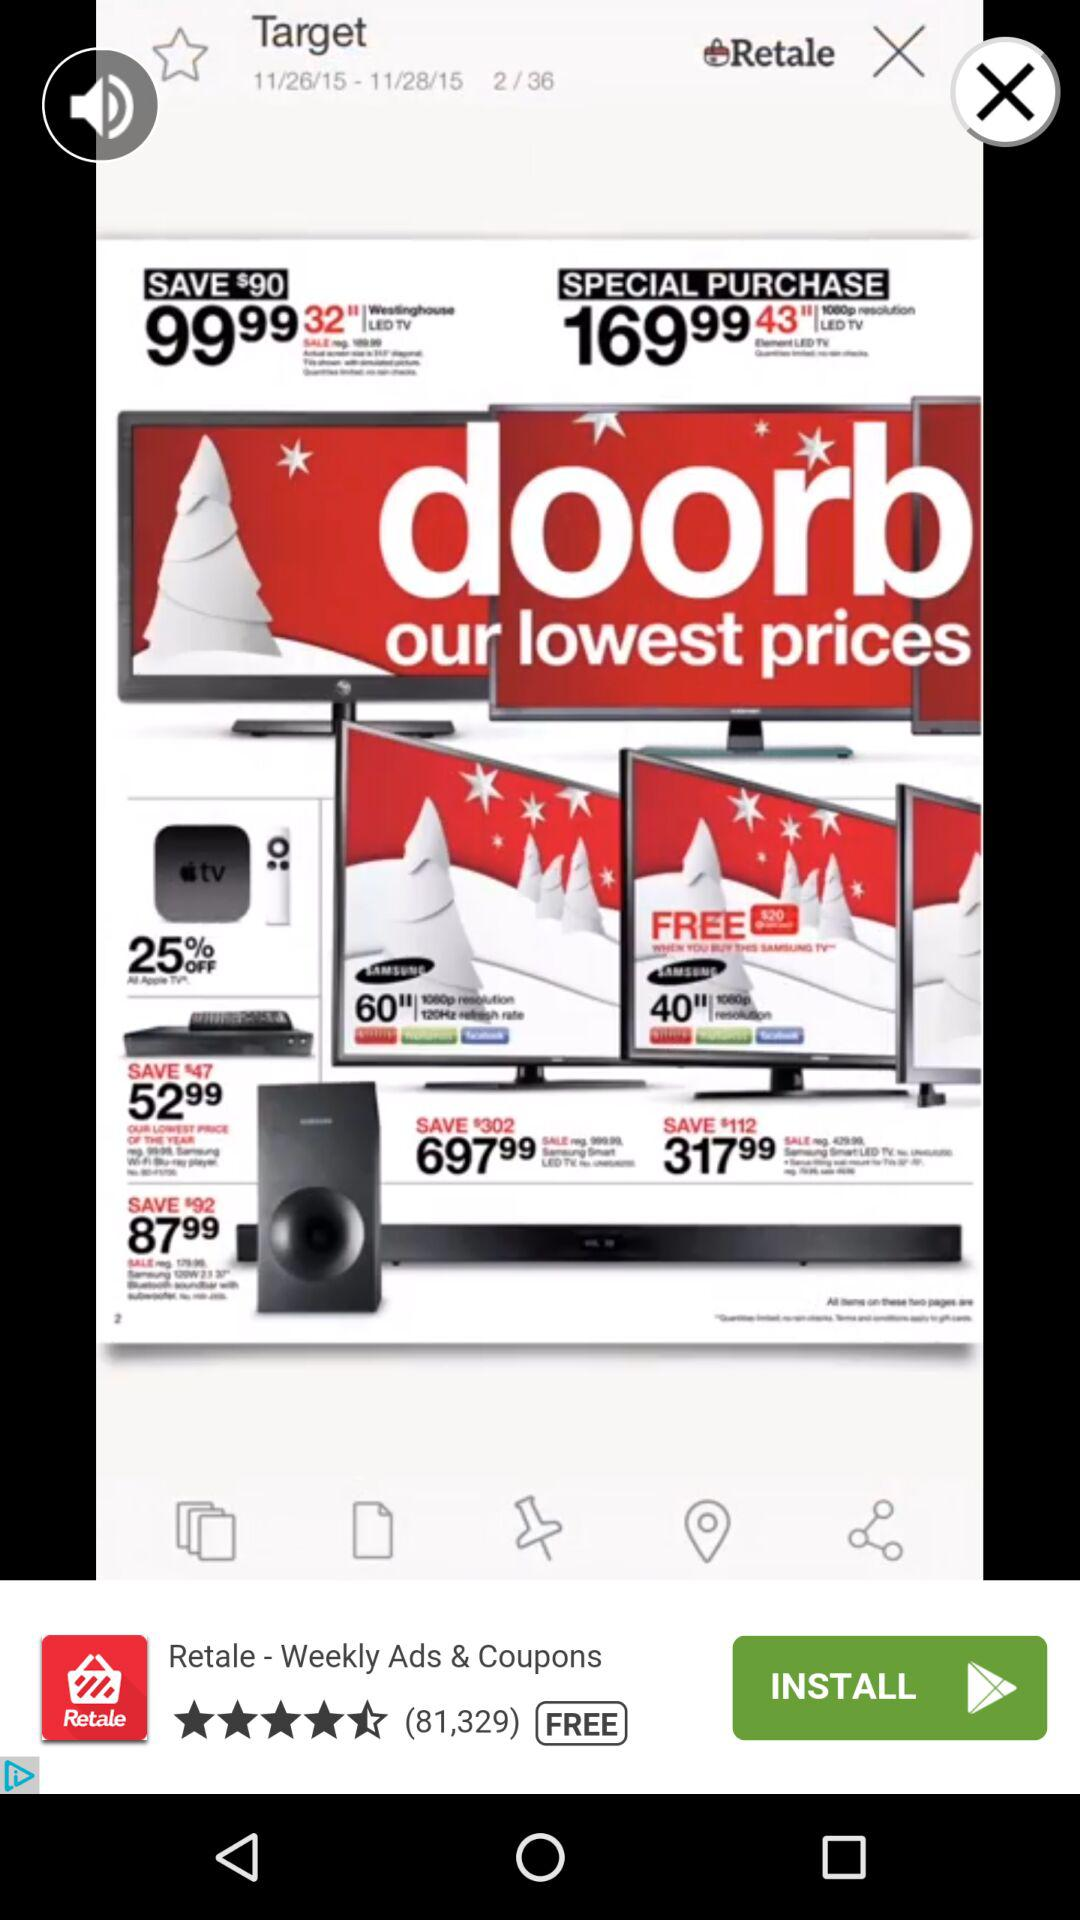How many days left in the sale?
Answer the question using a single word or phrase. 2 